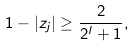<formula> <loc_0><loc_0><loc_500><loc_500>1 - | z _ { j } | \geq \frac { 2 } { 2 ^ { l } + 1 } ,</formula> 